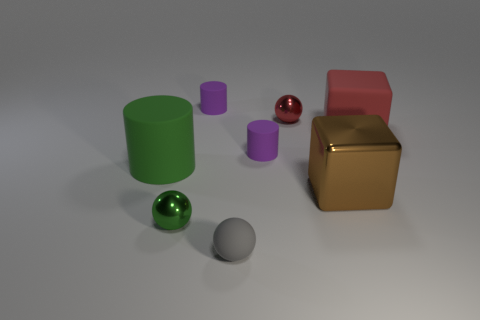What materials do the objects appear to be made of? The objects seem to have a variety of materials. The cylindrical and spherical ones exhibit shiny, reflective surfaces similar to metals or polished stone. The cube on the right looks metallic with a textured surface, whereas the red cube appears matte, possibly resembling a plastic or painted wood material. How does the material of the objects affect the overall aesthetic? The contrast between the shiny metallic objects and the more subdued matte surfaces adds visual interest and diversity. The reflectivity of the metals brings dynamism through light play, which is balanced by the solid, unwavering appearance of the matte cube, presenting a harmonious yet engaging scene. 